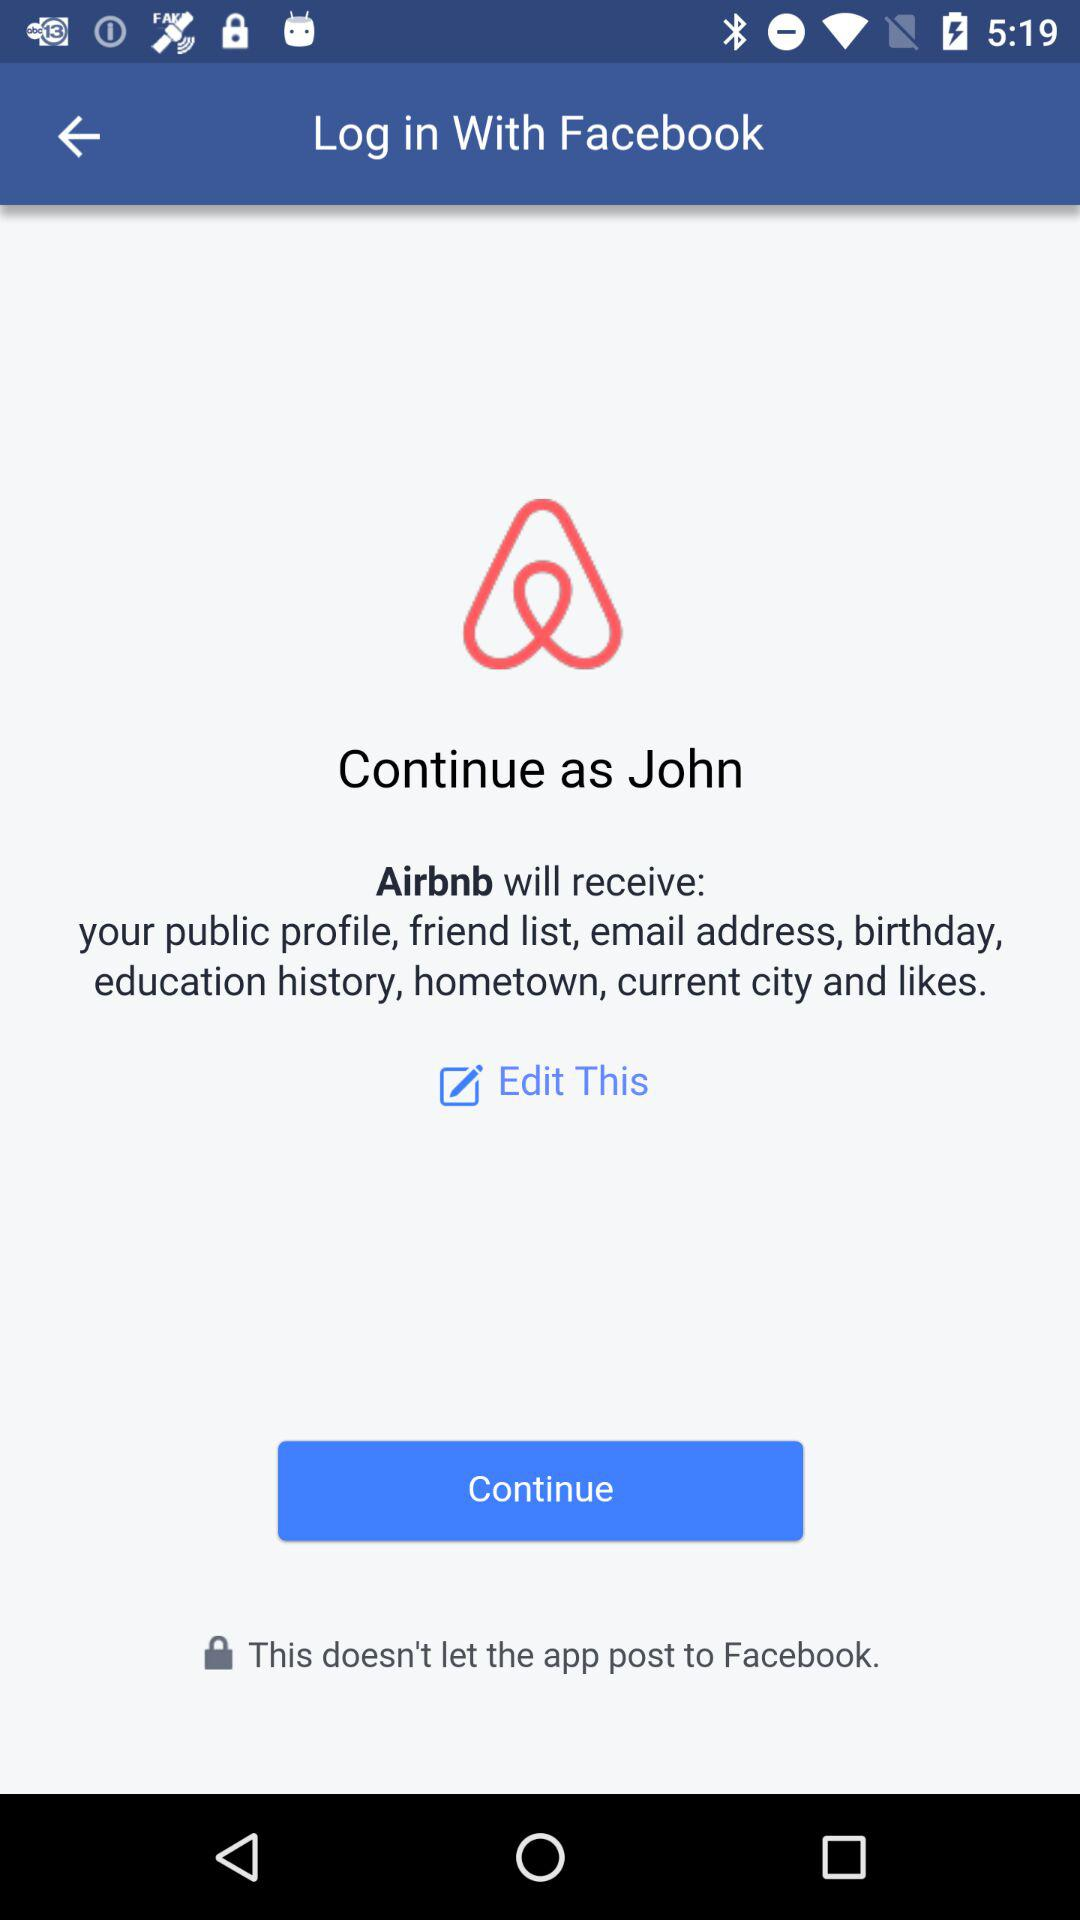What's the name of the user by whom the application can be continued? The name of the user is John. 